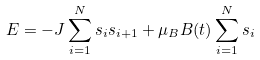Convert formula to latex. <formula><loc_0><loc_0><loc_500><loc_500>E = - J \sum _ { i = 1 } ^ { N } s _ { i } s _ { i + 1 } + \mu _ { B } B ( t ) \sum _ { i = 1 } ^ { N } s _ { i }</formula> 